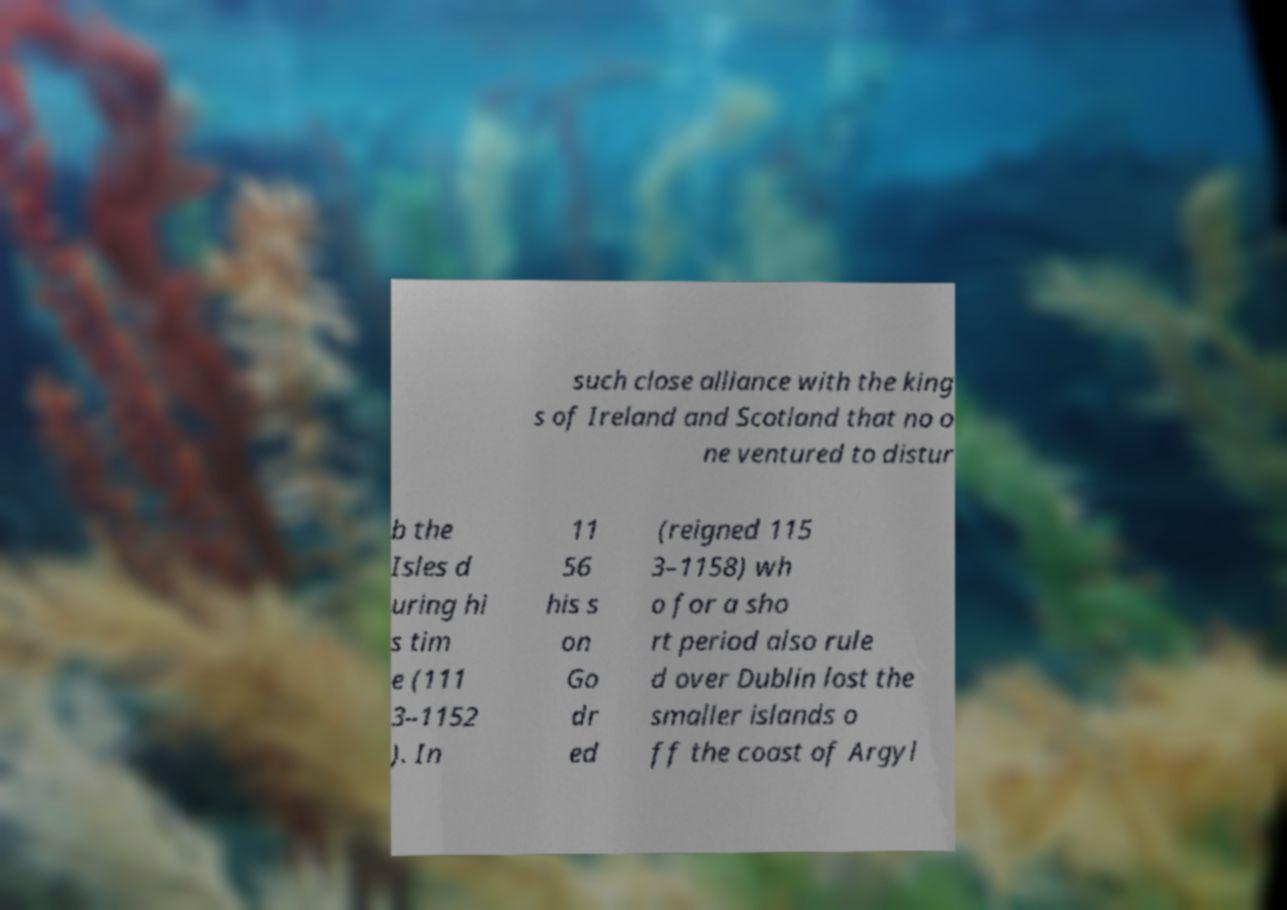Please identify and transcribe the text found in this image. such close alliance with the king s of Ireland and Scotland that no o ne ventured to distur b the Isles d uring hi s tim e (111 3–1152 ). In 11 56 his s on Go dr ed (reigned 115 3–1158) wh o for a sho rt period also rule d over Dublin lost the smaller islands o ff the coast of Argyl 